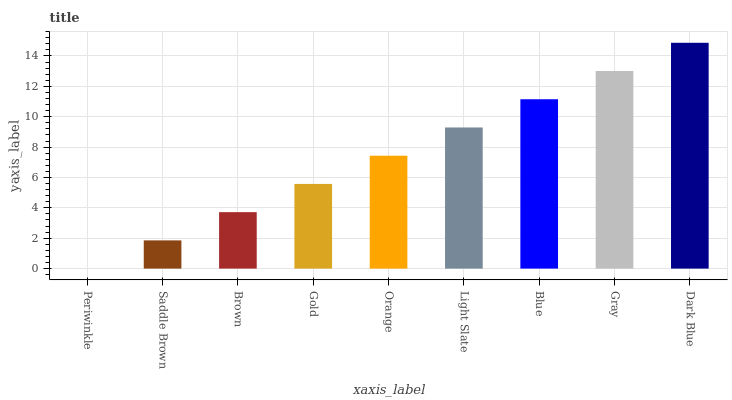Is Saddle Brown the minimum?
Answer yes or no. No. Is Saddle Brown the maximum?
Answer yes or no. No. Is Saddle Brown greater than Periwinkle?
Answer yes or no. Yes. Is Periwinkle less than Saddle Brown?
Answer yes or no. Yes. Is Periwinkle greater than Saddle Brown?
Answer yes or no. No. Is Saddle Brown less than Periwinkle?
Answer yes or no. No. Is Orange the high median?
Answer yes or no. Yes. Is Orange the low median?
Answer yes or no. Yes. Is Saddle Brown the high median?
Answer yes or no. No. Is Gray the low median?
Answer yes or no. No. 